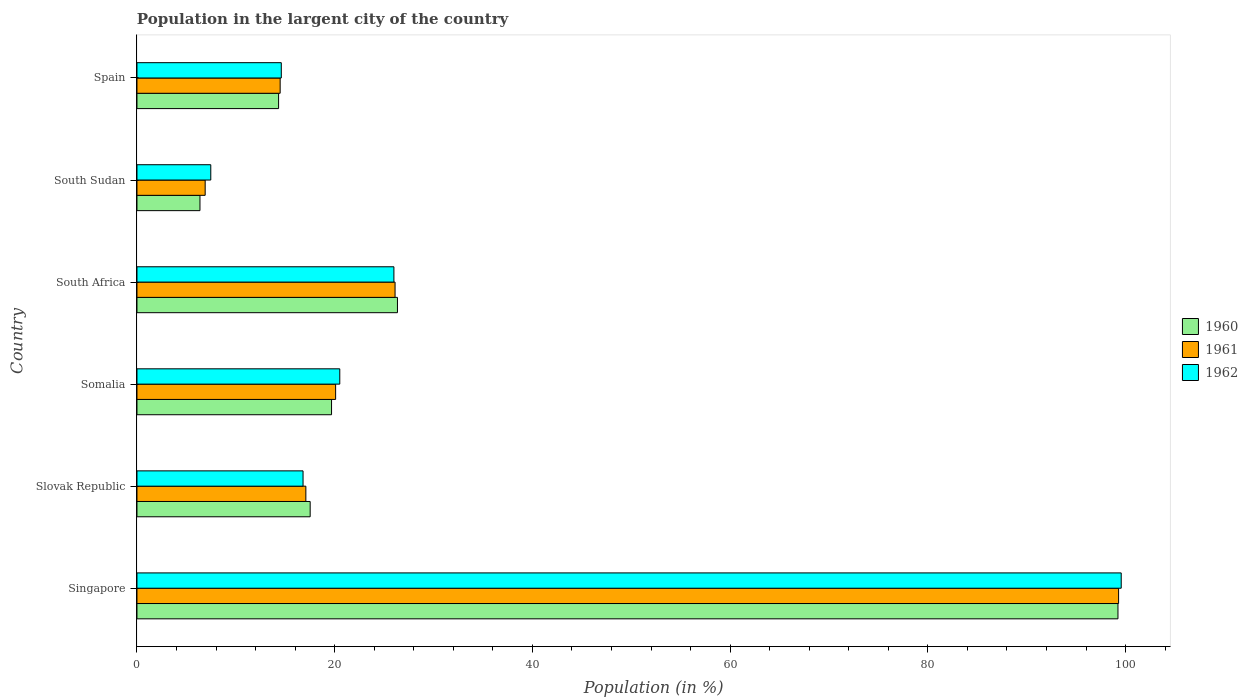How many different coloured bars are there?
Your response must be concise. 3. How many bars are there on the 4th tick from the bottom?
Provide a short and direct response. 3. What is the label of the 4th group of bars from the top?
Keep it short and to the point. Somalia. What is the percentage of population in the largent city in 1962 in Somalia?
Provide a short and direct response. 20.52. Across all countries, what is the maximum percentage of population in the largent city in 1961?
Your answer should be very brief. 99.29. Across all countries, what is the minimum percentage of population in the largent city in 1960?
Offer a terse response. 6.37. In which country was the percentage of population in the largent city in 1962 maximum?
Provide a short and direct response. Singapore. In which country was the percentage of population in the largent city in 1962 minimum?
Make the answer very short. South Sudan. What is the total percentage of population in the largent city in 1962 in the graph?
Ensure brevity in your answer.  184.93. What is the difference between the percentage of population in the largent city in 1962 in Singapore and that in Slovak Republic?
Your response must be concise. 82.76. What is the difference between the percentage of population in the largent city in 1962 in South Africa and the percentage of population in the largent city in 1960 in Singapore?
Ensure brevity in your answer.  -73.24. What is the average percentage of population in the largent city in 1961 per country?
Give a very brief answer. 30.66. What is the difference between the percentage of population in the largent city in 1962 and percentage of population in the largent city in 1961 in Slovak Republic?
Provide a succinct answer. -0.28. In how many countries, is the percentage of population in the largent city in 1960 greater than 60 %?
Your answer should be very brief. 1. What is the ratio of the percentage of population in the largent city in 1962 in Slovak Republic to that in South Sudan?
Make the answer very short. 2.25. Is the percentage of population in the largent city in 1960 in Slovak Republic less than that in South Africa?
Offer a terse response. Yes. What is the difference between the highest and the second highest percentage of population in the largent city in 1960?
Your answer should be very brief. 72.88. What is the difference between the highest and the lowest percentage of population in the largent city in 1961?
Provide a succinct answer. 92.39. Is the sum of the percentage of population in the largent city in 1960 in Somalia and South Sudan greater than the maximum percentage of population in the largent city in 1962 across all countries?
Offer a very short reply. No. What does the 1st bar from the top in Spain represents?
Your response must be concise. 1962. What does the 3rd bar from the bottom in Singapore represents?
Your answer should be very brief. 1962. Is it the case that in every country, the sum of the percentage of population in the largent city in 1960 and percentage of population in the largent city in 1961 is greater than the percentage of population in the largent city in 1962?
Your response must be concise. Yes. How many bars are there?
Make the answer very short. 18. What is the difference between two consecutive major ticks on the X-axis?
Offer a very short reply. 20. Does the graph contain any zero values?
Keep it short and to the point. No. How many legend labels are there?
Ensure brevity in your answer.  3. How are the legend labels stacked?
Make the answer very short. Vertical. What is the title of the graph?
Your response must be concise. Population in the largent city of the country. What is the label or title of the X-axis?
Offer a very short reply. Population (in %). What is the Population (in %) of 1960 in Singapore?
Offer a very short reply. 99.23. What is the Population (in %) of 1961 in Singapore?
Your answer should be compact. 99.29. What is the Population (in %) of 1962 in Singapore?
Provide a short and direct response. 99.56. What is the Population (in %) of 1960 in Slovak Republic?
Your answer should be compact. 17.52. What is the Population (in %) of 1961 in Slovak Republic?
Provide a short and direct response. 17.08. What is the Population (in %) of 1962 in Slovak Republic?
Provide a short and direct response. 16.8. What is the Population (in %) in 1960 in Somalia?
Make the answer very short. 19.68. What is the Population (in %) in 1961 in Somalia?
Provide a short and direct response. 20.1. What is the Population (in %) in 1962 in Somalia?
Keep it short and to the point. 20.52. What is the Population (in %) of 1960 in South Africa?
Offer a very short reply. 26.35. What is the Population (in %) of 1961 in South Africa?
Keep it short and to the point. 26.11. What is the Population (in %) in 1962 in South Africa?
Offer a very short reply. 25.99. What is the Population (in %) of 1960 in South Sudan?
Give a very brief answer. 6.37. What is the Population (in %) of 1961 in South Sudan?
Offer a terse response. 6.9. What is the Population (in %) of 1962 in South Sudan?
Make the answer very short. 7.47. What is the Population (in %) in 1960 in Spain?
Provide a succinct answer. 14.33. What is the Population (in %) in 1961 in Spain?
Ensure brevity in your answer.  14.48. What is the Population (in %) in 1962 in Spain?
Your response must be concise. 14.6. Across all countries, what is the maximum Population (in %) of 1960?
Keep it short and to the point. 99.23. Across all countries, what is the maximum Population (in %) of 1961?
Your response must be concise. 99.29. Across all countries, what is the maximum Population (in %) in 1962?
Your response must be concise. 99.56. Across all countries, what is the minimum Population (in %) in 1960?
Your answer should be very brief. 6.37. Across all countries, what is the minimum Population (in %) of 1961?
Your answer should be compact. 6.9. Across all countries, what is the minimum Population (in %) of 1962?
Give a very brief answer. 7.47. What is the total Population (in %) in 1960 in the graph?
Your answer should be compact. 183.48. What is the total Population (in %) in 1961 in the graph?
Provide a short and direct response. 183.96. What is the total Population (in %) in 1962 in the graph?
Provide a succinct answer. 184.93. What is the difference between the Population (in %) in 1960 in Singapore and that in Slovak Republic?
Your answer should be very brief. 81.71. What is the difference between the Population (in %) in 1961 in Singapore and that in Slovak Republic?
Keep it short and to the point. 82.21. What is the difference between the Population (in %) of 1962 in Singapore and that in Slovak Republic?
Keep it short and to the point. 82.76. What is the difference between the Population (in %) of 1960 in Singapore and that in Somalia?
Offer a terse response. 79.55. What is the difference between the Population (in %) in 1961 in Singapore and that in Somalia?
Keep it short and to the point. 79.2. What is the difference between the Population (in %) of 1962 in Singapore and that in Somalia?
Your answer should be compact. 79.04. What is the difference between the Population (in %) of 1960 in Singapore and that in South Africa?
Provide a short and direct response. 72.88. What is the difference between the Population (in %) of 1961 in Singapore and that in South Africa?
Provide a succinct answer. 73.19. What is the difference between the Population (in %) of 1962 in Singapore and that in South Africa?
Provide a succinct answer. 73.57. What is the difference between the Population (in %) of 1960 in Singapore and that in South Sudan?
Your response must be concise. 92.86. What is the difference between the Population (in %) in 1961 in Singapore and that in South Sudan?
Make the answer very short. 92.39. What is the difference between the Population (in %) of 1962 in Singapore and that in South Sudan?
Offer a terse response. 92.09. What is the difference between the Population (in %) in 1960 in Singapore and that in Spain?
Ensure brevity in your answer.  84.9. What is the difference between the Population (in %) of 1961 in Singapore and that in Spain?
Offer a very short reply. 84.81. What is the difference between the Population (in %) of 1962 in Singapore and that in Spain?
Ensure brevity in your answer.  84.96. What is the difference between the Population (in %) in 1960 in Slovak Republic and that in Somalia?
Provide a short and direct response. -2.16. What is the difference between the Population (in %) of 1961 in Slovak Republic and that in Somalia?
Your answer should be very brief. -3.01. What is the difference between the Population (in %) in 1962 in Slovak Republic and that in Somalia?
Your response must be concise. -3.72. What is the difference between the Population (in %) in 1960 in Slovak Republic and that in South Africa?
Offer a very short reply. -8.83. What is the difference between the Population (in %) in 1961 in Slovak Republic and that in South Africa?
Provide a succinct answer. -9.02. What is the difference between the Population (in %) in 1962 in Slovak Republic and that in South Africa?
Provide a short and direct response. -9.19. What is the difference between the Population (in %) in 1960 in Slovak Republic and that in South Sudan?
Your response must be concise. 11.15. What is the difference between the Population (in %) in 1961 in Slovak Republic and that in South Sudan?
Make the answer very short. 10.18. What is the difference between the Population (in %) of 1962 in Slovak Republic and that in South Sudan?
Ensure brevity in your answer.  9.33. What is the difference between the Population (in %) in 1960 in Slovak Republic and that in Spain?
Offer a terse response. 3.2. What is the difference between the Population (in %) of 1961 in Slovak Republic and that in Spain?
Provide a short and direct response. 2.6. What is the difference between the Population (in %) of 1962 in Slovak Republic and that in Spain?
Provide a succinct answer. 2.2. What is the difference between the Population (in %) of 1960 in Somalia and that in South Africa?
Keep it short and to the point. -6.67. What is the difference between the Population (in %) of 1961 in Somalia and that in South Africa?
Offer a terse response. -6.01. What is the difference between the Population (in %) in 1962 in Somalia and that in South Africa?
Offer a terse response. -5.47. What is the difference between the Population (in %) in 1960 in Somalia and that in South Sudan?
Keep it short and to the point. 13.31. What is the difference between the Population (in %) in 1961 in Somalia and that in South Sudan?
Give a very brief answer. 13.2. What is the difference between the Population (in %) in 1962 in Somalia and that in South Sudan?
Your answer should be compact. 13.05. What is the difference between the Population (in %) in 1960 in Somalia and that in Spain?
Your answer should be very brief. 5.36. What is the difference between the Population (in %) of 1961 in Somalia and that in Spain?
Offer a terse response. 5.61. What is the difference between the Population (in %) in 1962 in Somalia and that in Spain?
Provide a short and direct response. 5.92. What is the difference between the Population (in %) in 1960 in South Africa and that in South Sudan?
Give a very brief answer. 19.97. What is the difference between the Population (in %) of 1961 in South Africa and that in South Sudan?
Your answer should be compact. 19.21. What is the difference between the Population (in %) of 1962 in South Africa and that in South Sudan?
Your response must be concise. 18.52. What is the difference between the Population (in %) in 1960 in South Africa and that in Spain?
Make the answer very short. 12.02. What is the difference between the Population (in %) of 1961 in South Africa and that in Spain?
Keep it short and to the point. 11.62. What is the difference between the Population (in %) of 1962 in South Africa and that in Spain?
Provide a succinct answer. 11.39. What is the difference between the Population (in %) of 1960 in South Sudan and that in Spain?
Your response must be concise. -7.95. What is the difference between the Population (in %) of 1961 in South Sudan and that in Spain?
Make the answer very short. -7.58. What is the difference between the Population (in %) of 1962 in South Sudan and that in Spain?
Keep it short and to the point. -7.13. What is the difference between the Population (in %) of 1960 in Singapore and the Population (in %) of 1961 in Slovak Republic?
Give a very brief answer. 82.15. What is the difference between the Population (in %) of 1960 in Singapore and the Population (in %) of 1962 in Slovak Republic?
Your response must be concise. 82.43. What is the difference between the Population (in %) in 1961 in Singapore and the Population (in %) in 1962 in Slovak Republic?
Give a very brief answer. 82.49. What is the difference between the Population (in %) of 1960 in Singapore and the Population (in %) of 1961 in Somalia?
Give a very brief answer. 79.13. What is the difference between the Population (in %) of 1960 in Singapore and the Population (in %) of 1962 in Somalia?
Offer a very short reply. 78.71. What is the difference between the Population (in %) in 1961 in Singapore and the Population (in %) in 1962 in Somalia?
Your answer should be compact. 78.78. What is the difference between the Population (in %) in 1960 in Singapore and the Population (in %) in 1961 in South Africa?
Ensure brevity in your answer.  73.12. What is the difference between the Population (in %) in 1960 in Singapore and the Population (in %) in 1962 in South Africa?
Offer a terse response. 73.24. What is the difference between the Population (in %) of 1961 in Singapore and the Population (in %) of 1962 in South Africa?
Offer a very short reply. 73.3. What is the difference between the Population (in %) of 1960 in Singapore and the Population (in %) of 1961 in South Sudan?
Provide a short and direct response. 92.33. What is the difference between the Population (in %) in 1960 in Singapore and the Population (in %) in 1962 in South Sudan?
Your response must be concise. 91.76. What is the difference between the Population (in %) in 1961 in Singapore and the Population (in %) in 1962 in South Sudan?
Make the answer very short. 91.83. What is the difference between the Population (in %) in 1960 in Singapore and the Population (in %) in 1961 in Spain?
Make the answer very short. 84.75. What is the difference between the Population (in %) in 1960 in Singapore and the Population (in %) in 1962 in Spain?
Keep it short and to the point. 84.63. What is the difference between the Population (in %) in 1961 in Singapore and the Population (in %) in 1962 in Spain?
Your response must be concise. 84.69. What is the difference between the Population (in %) of 1960 in Slovak Republic and the Population (in %) of 1961 in Somalia?
Offer a very short reply. -2.57. What is the difference between the Population (in %) of 1960 in Slovak Republic and the Population (in %) of 1962 in Somalia?
Make the answer very short. -2.99. What is the difference between the Population (in %) in 1961 in Slovak Republic and the Population (in %) in 1962 in Somalia?
Offer a terse response. -3.43. What is the difference between the Population (in %) in 1960 in Slovak Republic and the Population (in %) in 1961 in South Africa?
Make the answer very short. -8.59. What is the difference between the Population (in %) in 1960 in Slovak Republic and the Population (in %) in 1962 in South Africa?
Offer a very short reply. -8.47. What is the difference between the Population (in %) of 1961 in Slovak Republic and the Population (in %) of 1962 in South Africa?
Your answer should be compact. -8.91. What is the difference between the Population (in %) of 1960 in Slovak Republic and the Population (in %) of 1961 in South Sudan?
Your answer should be compact. 10.62. What is the difference between the Population (in %) of 1960 in Slovak Republic and the Population (in %) of 1962 in South Sudan?
Your answer should be compact. 10.05. What is the difference between the Population (in %) of 1961 in Slovak Republic and the Population (in %) of 1962 in South Sudan?
Your answer should be very brief. 9.62. What is the difference between the Population (in %) of 1960 in Slovak Republic and the Population (in %) of 1961 in Spain?
Offer a terse response. 3.04. What is the difference between the Population (in %) of 1960 in Slovak Republic and the Population (in %) of 1962 in Spain?
Your answer should be very brief. 2.92. What is the difference between the Population (in %) of 1961 in Slovak Republic and the Population (in %) of 1962 in Spain?
Provide a succinct answer. 2.48. What is the difference between the Population (in %) of 1960 in Somalia and the Population (in %) of 1961 in South Africa?
Your answer should be compact. -6.42. What is the difference between the Population (in %) of 1960 in Somalia and the Population (in %) of 1962 in South Africa?
Make the answer very short. -6.31. What is the difference between the Population (in %) of 1961 in Somalia and the Population (in %) of 1962 in South Africa?
Give a very brief answer. -5.89. What is the difference between the Population (in %) of 1960 in Somalia and the Population (in %) of 1961 in South Sudan?
Make the answer very short. 12.78. What is the difference between the Population (in %) in 1960 in Somalia and the Population (in %) in 1962 in South Sudan?
Provide a short and direct response. 12.22. What is the difference between the Population (in %) in 1961 in Somalia and the Population (in %) in 1962 in South Sudan?
Keep it short and to the point. 12.63. What is the difference between the Population (in %) in 1960 in Somalia and the Population (in %) in 1961 in Spain?
Your response must be concise. 5.2. What is the difference between the Population (in %) in 1960 in Somalia and the Population (in %) in 1962 in Spain?
Provide a short and direct response. 5.08. What is the difference between the Population (in %) of 1961 in Somalia and the Population (in %) of 1962 in Spain?
Your answer should be compact. 5.5. What is the difference between the Population (in %) in 1960 in South Africa and the Population (in %) in 1961 in South Sudan?
Offer a very short reply. 19.45. What is the difference between the Population (in %) in 1960 in South Africa and the Population (in %) in 1962 in South Sudan?
Ensure brevity in your answer.  18.88. What is the difference between the Population (in %) of 1961 in South Africa and the Population (in %) of 1962 in South Sudan?
Keep it short and to the point. 18.64. What is the difference between the Population (in %) in 1960 in South Africa and the Population (in %) in 1961 in Spain?
Give a very brief answer. 11.86. What is the difference between the Population (in %) of 1960 in South Africa and the Population (in %) of 1962 in Spain?
Ensure brevity in your answer.  11.75. What is the difference between the Population (in %) in 1961 in South Africa and the Population (in %) in 1962 in Spain?
Your answer should be compact. 11.51. What is the difference between the Population (in %) in 1960 in South Sudan and the Population (in %) in 1961 in Spain?
Your answer should be very brief. -8.11. What is the difference between the Population (in %) of 1960 in South Sudan and the Population (in %) of 1962 in Spain?
Offer a very short reply. -8.23. What is the difference between the Population (in %) in 1961 in South Sudan and the Population (in %) in 1962 in Spain?
Offer a very short reply. -7.7. What is the average Population (in %) in 1960 per country?
Ensure brevity in your answer.  30.58. What is the average Population (in %) in 1961 per country?
Your response must be concise. 30.66. What is the average Population (in %) in 1962 per country?
Provide a short and direct response. 30.82. What is the difference between the Population (in %) in 1960 and Population (in %) in 1961 in Singapore?
Give a very brief answer. -0.06. What is the difference between the Population (in %) in 1960 and Population (in %) in 1962 in Singapore?
Keep it short and to the point. -0.33. What is the difference between the Population (in %) of 1961 and Population (in %) of 1962 in Singapore?
Give a very brief answer. -0.27. What is the difference between the Population (in %) of 1960 and Population (in %) of 1961 in Slovak Republic?
Ensure brevity in your answer.  0.44. What is the difference between the Population (in %) in 1960 and Population (in %) in 1962 in Slovak Republic?
Your answer should be compact. 0.72. What is the difference between the Population (in %) of 1961 and Population (in %) of 1962 in Slovak Republic?
Your answer should be compact. 0.28. What is the difference between the Population (in %) in 1960 and Population (in %) in 1961 in Somalia?
Ensure brevity in your answer.  -0.41. What is the difference between the Population (in %) of 1960 and Population (in %) of 1962 in Somalia?
Your answer should be very brief. -0.83. What is the difference between the Population (in %) in 1961 and Population (in %) in 1962 in Somalia?
Provide a short and direct response. -0.42. What is the difference between the Population (in %) of 1960 and Population (in %) of 1961 in South Africa?
Offer a terse response. 0.24. What is the difference between the Population (in %) in 1960 and Population (in %) in 1962 in South Africa?
Keep it short and to the point. 0.36. What is the difference between the Population (in %) of 1961 and Population (in %) of 1962 in South Africa?
Provide a short and direct response. 0.12. What is the difference between the Population (in %) of 1960 and Population (in %) of 1961 in South Sudan?
Ensure brevity in your answer.  -0.53. What is the difference between the Population (in %) in 1960 and Population (in %) in 1962 in South Sudan?
Offer a terse response. -1.09. What is the difference between the Population (in %) of 1961 and Population (in %) of 1962 in South Sudan?
Offer a terse response. -0.57. What is the difference between the Population (in %) of 1960 and Population (in %) of 1961 in Spain?
Offer a terse response. -0.16. What is the difference between the Population (in %) of 1960 and Population (in %) of 1962 in Spain?
Keep it short and to the point. -0.27. What is the difference between the Population (in %) of 1961 and Population (in %) of 1962 in Spain?
Provide a succinct answer. -0.12. What is the ratio of the Population (in %) in 1960 in Singapore to that in Slovak Republic?
Your answer should be compact. 5.66. What is the ratio of the Population (in %) of 1961 in Singapore to that in Slovak Republic?
Provide a short and direct response. 5.81. What is the ratio of the Population (in %) in 1962 in Singapore to that in Slovak Republic?
Provide a succinct answer. 5.93. What is the ratio of the Population (in %) in 1960 in Singapore to that in Somalia?
Provide a succinct answer. 5.04. What is the ratio of the Population (in %) in 1961 in Singapore to that in Somalia?
Your answer should be compact. 4.94. What is the ratio of the Population (in %) of 1962 in Singapore to that in Somalia?
Offer a terse response. 4.85. What is the ratio of the Population (in %) in 1960 in Singapore to that in South Africa?
Make the answer very short. 3.77. What is the ratio of the Population (in %) of 1961 in Singapore to that in South Africa?
Your answer should be very brief. 3.8. What is the ratio of the Population (in %) in 1962 in Singapore to that in South Africa?
Keep it short and to the point. 3.83. What is the ratio of the Population (in %) of 1960 in Singapore to that in South Sudan?
Offer a very short reply. 15.57. What is the ratio of the Population (in %) in 1961 in Singapore to that in South Sudan?
Offer a terse response. 14.39. What is the ratio of the Population (in %) of 1962 in Singapore to that in South Sudan?
Offer a very short reply. 13.33. What is the ratio of the Population (in %) in 1960 in Singapore to that in Spain?
Provide a short and direct response. 6.93. What is the ratio of the Population (in %) of 1961 in Singapore to that in Spain?
Your answer should be compact. 6.86. What is the ratio of the Population (in %) of 1962 in Singapore to that in Spain?
Give a very brief answer. 6.82. What is the ratio of the Population (in %) in 1960 in Slovak Republic to that in Somalia?
Offer a very short reply. 0.89. What is the ratio of the Population (in %) in 1961 in Slovak Republic to that in Somalia?
Offer a terse response. 0.85. What is the ratio of the Population (in %) of 1962 in Slovak Republic to that in Somalia?
Make the answer very short. 0.82. What is the ratio of the Population (in %) of 1960 in Slovak Republic to that in South Africa?
Keep it short and to the point. 0.67. What is the ratio of the Population (in %) in 1961 in Slovak Republic to that in South Africa?
Offer a very short reply. 0.65. What is the ratio of the Population (in %) of 1962 in Slovak Republic to that in South Africa?
Offer a very short reply. 0.65. What is the ratio of the Population (in %) in 1960 in Slovak Republic to that in South Sudan?
Provide a short and direct response. 2.75. What is the ratio of the Population (in %) in 1961 in Slovak Republic to that in South Sudan?
Your response must be concise. 2.48. What is the ratio of the Population (in %) of 1962 in Slovak Republic to that in South Sudan?
Your answer should be compact. 2.25. What is the ratio of the Population (in %) of 1960 in Slovak Republic to that in Spain?
Your answer should be very brief. 1.22. What is the ratio of the Population (in %) in 1961 in Slovak Republic to that in Spain?
Give a very brief answer. 1.18. What is the ratio of the Population (in %) in 1962 in Slovak Republic to that in Spain?
Provide a succinct answer. 1.15. What is the ratio of the Population (in %) of 1960 in Somalia to that in South Africa?
Give a very brief answer. 0.75. What is the ratio of the Population (in %) of 1961 in Somalia to that in South Africa?
Provide a short and direct response. 0.77. What is the ratio of the Population (in %) of 1962 in Somalia to that in South Africa?
Give a very brief answer. 0.79. What is the ratio of the Population (in %) in 1960 in Somalia to that in South Sudan?
Ensure brevity in your answer.  3.09. What is the ratio of the Population (in %) of 1961 in Somalia to that in South Sudan?
Your answer should be compact. 2.91. What is the ratio of the Population (in %) in 1962 in Somalia to that in South Sudan?
Offer a very short reply. 2.75. What is the ratio of the Population (in %) of 1960 in Somalia to that in Spain?
Make the answer very short. 1.37. What is the ratio of the Population (in %) of 1961 in Somalia to that in Spain?
Your answer should be compact. 1.39. What is the ratio of the Population (in %) of 1962 in Somalia to that in Spain?
Provide a short and direct response. 1.41. What is the ratio of the Population (in %) in 1960 in South Africa to that in South Sudan?
Offer a very short reply. 4.13. What is the ratio of the Population (in %) of 1961 in South Africa to that in South Sudan?
Give a very brief answer. 3.78. What is the ratio of the Population (in %) in 1962 in South Africa to that in South Sudan?
Provide a succinct answer. 3.48. What is the ratio of the Population (in %) in 1960 in South Africa to that in Spain?
Keep it short and to the point. 1.84. What is the ratio of the Population (in %) of 1961 in South Africa to that in Spain?
Your answer should be very brief. 1.8. What is the ratio of the Population (in %) of 1962 in South Africa to that in Spain?
Your answer should be very brief. 1.78. What is the ratio of the Population (in %) in 1960 in South Sudan to that in Spain?
Your answer should be compact. 0.44. What is the ratio of the Population (in %) of 1961 in South Sudan to that in Spain?
Keep it short and to the point. 0.48. What is the ratio of the Population (in %) of 1962 in South Sudan to that in Spain?
Offer a terse response. 0.51. What is the difference between the highest and the second highest Population (in %) of 1960?
Ensure brevity in your answer.  72.88. What is the difference between the highest and the second highest Population (in %) of 1961?
Offer a terse response. 73.19. What is the difference between the highest and the second highest Population (in %) in 1962?
Give a very brief answer. 73.57. What is the difference between the highest and the lowest Population (in %) in 1960?
Give a very brief answer. 92.86. What is the difference between the highest and the lowest Population (in %) of 1961?
Give a very brief answer. 92.39. What is the difference between the highest and the lowest Population (in %) of 1962?
Provide a succinct answer. 92.09. 